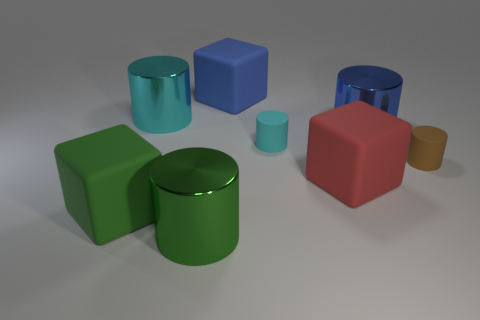Subtract all large green cubes. How many cubes are left? 2 Subtract 1 cubes. How many cubes are left? 2 Add 2 large blue shiny objects. How many objects exist? 10 Subtract all cubes. How many objects are left? 5 Add 3 red things. How many red things are left? 4 Add 3 big red matte cubes. How many big red matte cubes exist? 4 Subtract all green cylinders. How many cylinders are left? 4 Subtract 0 yellow cylinders. How many objects are left? 8 Subtract all red cylinders. Subtract all green spheres. How many cylinders are left? 5 Subtract all blue cylinders. How many yellow cubes are left? 0 